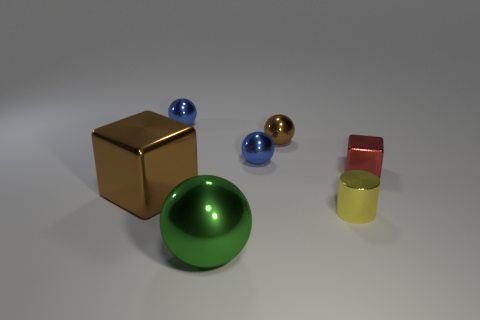There is a metal object in front of the cylinder; is it the same size as the brown shiny object to the left of the large sphere?
Make the answer very short. Yes. There is a brown object in front of the block right of the big shiny object in front of the small yellow cylinder; what is its material?
Make the answer very short. Metal. Does the tiny red thing have the same shape as the tiny yellow thing?
Provide a short and direct response. No. There is another thing that is the same shape as the small red metal object; what is it made of?
Your response must be concise. Metal. What number of big metallic spheres are the same color as the small shiny block?
Your response must be concise. 0. There is another block that is made of the same material as the tiny block; what size is it?
Offer a very short reply. Large. What number of green objects are either tiny cubes or big metal balls?
Your answer should be compact. 1. How many tiny blue shiny objects are on the right side of the thing in front of the metal cylinder?
Provide a succinct answer. 1. Is the number of metallic balls in front of the small yellow metallic cylinder greater than the number of large shiny things on the left side of the big metallic cube?
Provide a short and direct response. Yes. What material is the tiny yellow thing?
Provide a short and direct response. Metal. 